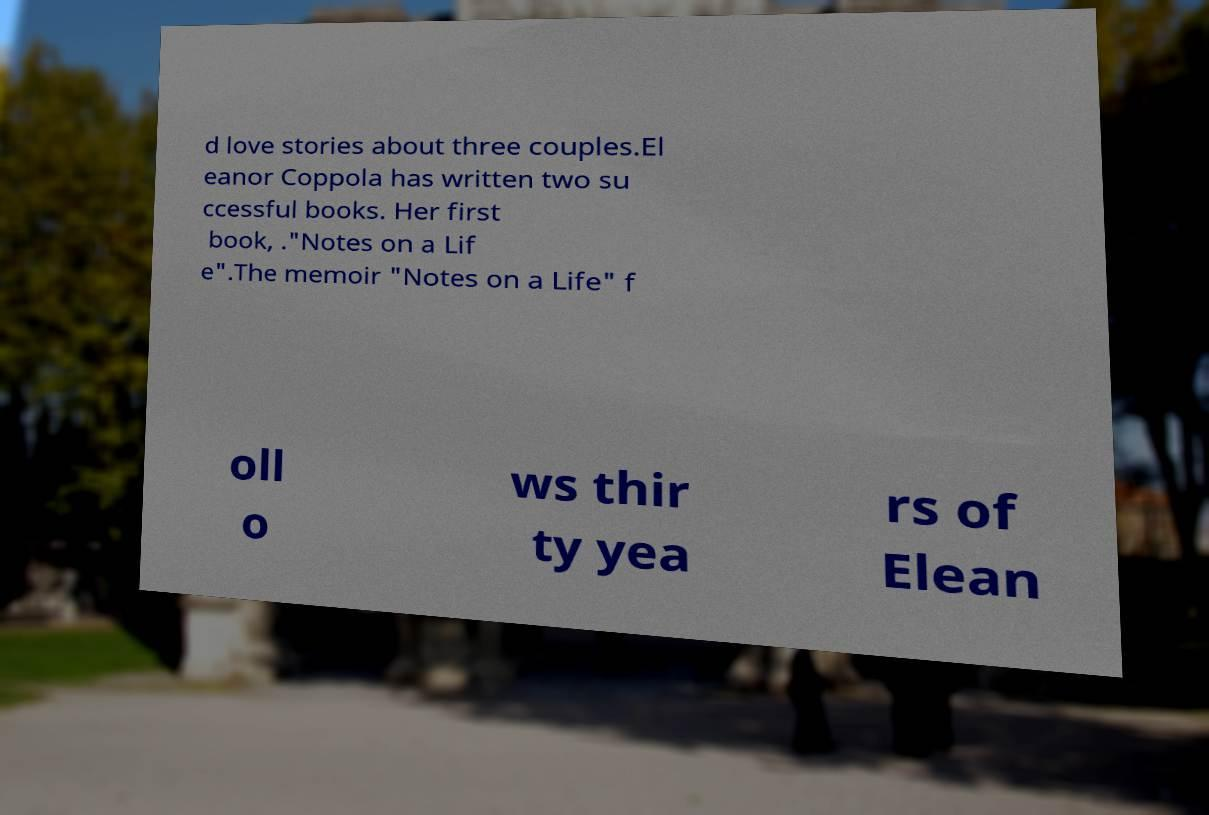What messages or text are displayed in this image? I need them in a readable, typed format. d love stories about three couples.El eanor Coppola has written two su ccessful books. Her first book, ."Notes on a Lif e".The memoir "Notes on a Life" f oll o ws thir ty yea rs of Elean 